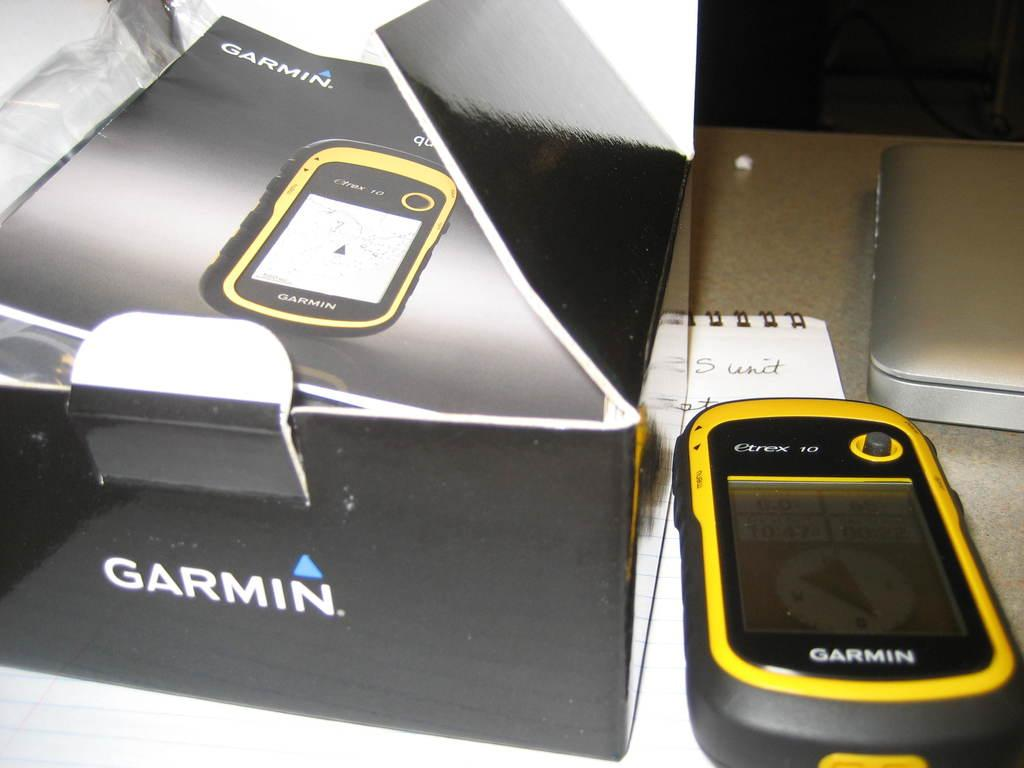<image>
Provide a brief description of the given image. A Garmin navigation device sitting next to it's box. 